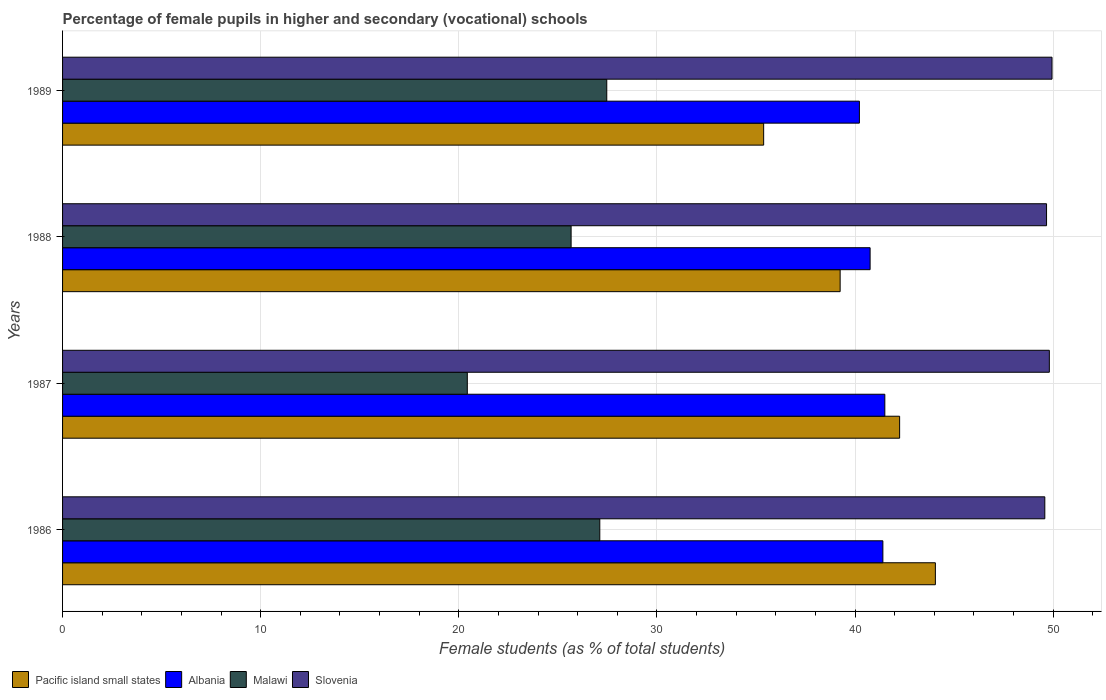How many different coloured bars are there?
Provide a short and direct response. 4. Are the number of bars per tick equal to the number of legend labels?
Offer a very short reply. Yes. What is the percentage of female pupils in higher and secondary schools in Malawi in 1987?
Provide a succinct answer. 20.43. Across all years, what is the maximum percentage of female pupils in higher and secondary schools in Slovenia?
Your answer should be very brief. 49.94. Across all years, what is the minimum percentage of female pupils in higher and secondary schools in Pacific island small states?
Offer a terse response. 35.39. In which year was the percentage of female pupils in higher and secondary schools in Albania maximum?
Offer a very short reply. 1987. What is the total percentage of female pupils in higher and secondary schools in Pacific island small states in the graph?
Your answer should be very brief. 160.95. What is the difference between the percentage of female pupils in higher and secondary schools in Malawi in 1987 and that in 1988?
Make the answer very short. -5.24. What is the difference between the percentage of female pupils in higher and secondary schools in Pacific island small states in 1988 and the percentage of female pupils in higher and secondary schools in Slovenia in 1989?
Offer a very short reply. -10.69. What is the average percentage of female pupils in higher and secondary schools in Pacific island small states per year?
Your answer should be compact. 40.24. In the year 1989, what is the difference between the percentage of female pupils in higher and secondary schools in Malawi and percentage of female pupils in higher and secondary schools in Albania?
Ensure brevity in your answer.  -12.75. In how many years, is the percentage of female pupils in higher and secondary schools in Slovenia greater than 42 %?
Provide a short and direct response. 4. What is the ratio of the percentage of female pupils in higher and secondary schools in Pacific island small states in 1987 to that in 1988?
Offer a terse response. 1.08. Is the percentage of female pupils in higher and secondary schools in Albania in 1986 less than that in 1989?
Your answer should be very brief. No. Is the difference between the percentage of female pupils in higher and secondary schools in Malawi in 1988 and 1989 greater than the difference between the percentage of female pupils in higher and secondary schools in Albania in 1988 and 1989?
Your response must be concise. No. What is the difference between the highest and the second highest percentage of female pupils in higher and secondary schools in Malawi?
Give a very brief answer. 0.35. What is the difference between the highest and the lowest percentage of female pupils in higher and secondary schools in Slovenia?
Offer a terse response. 0.36. Is the sum of the percentage of female pupils in higher and secondary schools in Slovenia in 1986 and 1988 greater than the maximum percentage of female pupils in higher and secondary schools in Malawi across all years?
Make the answer very short. Yes. Is it the case that in every year, the sum of the percentage of female pupils in higher and secondary schools in Slovenia and percentage of female pupils in higher and secondary schools in Malawi is greater than the sum of percentage of female pupils in higher and secondary schools in Albania and percentage of female pupils in higher and secondary schools in Pacific island small states?
Keep it short and to the point. No. What does the 2nd bar from the top in 1987 represents?
Provide a short and direct response. Malawi. What does the 1st bar from the bottom in 1988 represents?
Provide a short and direct response. Pacific island small states. Are all the bars in the graph horizontal?
Offer a very short reply. Yes. How many years are there in the graph?
Provide a succinct answer. 4. How many legend labels are there?
Your response must be concise. 4. How are the legend labels stacked?
Keep it short and to the point. Horizontal. What is the title of the graph?
Provide a succinct answer. Percentage of female pupils in higher and secondary (vocational) schools. What is the label or title of the X-axis?
Your answer should be very brief. Female students (as % of total students). What is the Female students (as % of total students) in Pacific island small states in 1986?
Your response must be concise. 44.06. What is the Female students (as % of total students) in Albania in 1986?
Offer a terse response. 41.41. What is the Female students (as % of total students) in Malawi in 1986?
Make the answer very short. 27.12. What is the Female students (as % of total students) of Slovenia in 1986?
Make the answer very short. 49.58. What is the Female students (as % of total students) in Pacific island small states in 1987?
Provide a succinct answer. 42.25. What is the Female students (as % of total students) in Albania in 1987?
Provide a short and direct response. 41.51. What is the Female students (as % of total students) in Malawi in 1987?
Your answer should be compact. 20.43. What is the Female students (as % of total students) of Slovenia in 1987?
Your answer should be compact. 49.81. What is the Female students (as % of total students) of Pacific island small states in 1988?
Your response must be concise. 39.25. What is the Female students (as % of total students) of Albania in 1988?
Offer a terse response. 40.76. What is the Female students (as % of total students) of Malawi in 1988?
Offer a terse response. 25.67. What is the Female students (as % of total students) in Slovenia in 1988?
Keep it short and to the point. 49.67. What is the Female students (as % of total students) of Pacific island small states in 1989?
Ensure brevity in your answer.  35.39. What is the Female students (as % of total students) in Albania in 1989?
Offer a terse response. 40.22. What is the Female students (as % of total students) in Malawi in 1989?
Your answer should be compact. 27.47. What is the Female students (as % of total students) in Slovenia in 1989?
Your answer should be very brief. 49.94. Across all years, what is the maximum Female students (as % of total students) of Pacific island small states?
Provide a succinct answer. 44.06. Across all years, what is the maximum Female students (as % of total students) of Albania?
Provide a succinct answer. 41.51. Across all years, what is the maximum Female students (as % of total students) in Malawi?
Make the answer very short. 27.47. Across all years, what is the maximum Female students (as % of total students) in Slovenia?
Provide a short and direct response. 49.94. Across all years, what is the minimum Female students (as % of total students) of Pacific island small states?
Your response must be concise. 35.39. Across all years, what is the minimum Female students (as % of total students) of Albania?
Provide a succinct answer. 40.22. Across all years, what is the minimum Female students (as % of total students) in Malawi?
Provide a short and direct response. 20.43. Across all years, what is the minimum Female students (as % of total students) of Slovenia?
Offer a terse response. 49.58. What is the total Female students (as % of total students) of Pacific island small states in the graph?
Offer a very short reply. 160.95. What is the total Female students (as % of total students) in Albania in the graph?
Keep it short and to the point. 163.9. What is the total Female students (as % of total students) in Malawi in the graph?
Your answer should be very brief. 100.69. What is the total Female students (as % of total students) in Slovenia in the graph?
Your response must be concise. 199. What is the difference between the Female students (as % of total students) in Pacific island small states in 1986 and that in 1987?
Your response must be concise. 1.8. What is the difference between the Female students (as % of total students) of Albania in 1986 and that in 1987?
Offer a very short reply. -0.1. What is the difference between the Female students (as % of total students) in Malawi in 1986 and that in 1987?
Provide a short and direct response. 6.69. What is the difference between the Female students (as % of total students) of Slovenia in 1986 and that in 1987?
Provide a succinct answer. -0.23. What is the difference between the Female students (as % of total students) in Pacific island small states in 1986 and that in 1988?
Your answer should be compact. 4.81. What is the difference between the Female students (as % of total students) of Albania in 1986 and that in 1988?
Keep it short and to the point. 0.64. What is the difference between the Female students (as % of total students) of Malawi in 1986 and that in 1988?
Make the answer very short. 1.45. What is the difference between the Female students (as % of total students) in Slovenia in 1986 and that in 1988?
Your answer should be very brief. -0.09. What is the difference between the Female students (as % of total students) in Pacific island small states in 1986 and that in 1989?
Keep it short and to the point. 8.67. What is the difference between the Female students (as % of total students) of Albania in 1986 and that in 1989?
Provide a short and direct response. 1.18. What is the difference between the Female students (as % of total students) of Malawi in 1986 and that in 1989?
Offer a terse response. -0.35. What is the difference between the Female students (as % of total students) of Slovenia in 1986 and that in 1989?
Provide a succinct answer. -0.36. What is the difference between the Female students (as % of total students) of Pacific island small states in 1987 and that in 1988?
Provide a short and direct response. 3. What is the difference between the Female students (as % of total students) in Albania in 1987 and that in 1988?
Offer a terse response. 0.74. What is the difference between the Female students (as % of total students) of Malawi in 1987 and that in 1988?
Offer a terse response. -5.24. What is the difference between the Female students (as % of total students) in Slovenia in 1987 and that in 1988?
Provide a succinct answer. 0.14. What is the difference between the Female students (as % of total students) in Pacific island small states in 1987 and that in 1989?
Offer a terse response. 6.86. What is the difference between the Female students (as % of total students) of Albania in 1987 and that in 1989?
Your answer should be very brief. 1.28. What is the difference between the Female students (as % of total students) of Malawi in 1987 and that in 1989?
Provide a succinct answer. -7.04. What is the difference between the Female students (as % of total students) in Slovenia in 1987 and that in 1989?
Provide a short and direct response. -0.14. What is the difference between the Female students (as % of total students) in Pacific island small states in 1988 and that in 1989?
Offer a terse response. 3.86. What is the difference between the Female students (as % of total students) in Albania in 1988 and that in 1989?
Offer a terse response. 0.54. What is the difference between the Female students (as % of total students) in Malawi in 1988 and that in 1989?
Make the answer very short. -1.8. What is the difference between the Female students (as % of total students) in Slovenia in 1988 and that in 1989?
Offer a terse response. -0.28. What is the difference between the Female students (as % of total students) in Pacific island small states in 1986 and the Female students (as % of total students) in Albania in 1987?
Offer a terse response. 2.55. What is the difference between the Female students (as % of total students) of Pacific island small states in 1986 and the Female students (as % of total students) of Malawi in 1987?
Give a very brief answer. 23.63. What is the difference between the Female students (as % of total students) in Pacific island small states in 1986 and the Female students (as % of total students) in Slovenia in 1987?
Give a very brief answer. -5.75. What is the difference between the Female students (as % of total students) of Albania in 1986 and the Female students (as % of total students) of Malawi in 1987?
Make the answer very short. 20.98. What is the difference between the Female students (as % of total students) in Albania in 1986 and the Female students (as % of total students) in Slovenia in 1987?
Offer a very short reply. -8.4. What is the difference between the Female students (as % of total students) of Malawi in 1986 and the Female students (as % of total students) of Slovenia in 1987?
Your answer should be very brief. -22.69. What is the difference between the Female students (as % of total students) in Pacific island small states in 1986 and the Female students (as % of total students) in Albania in 1988?
Provide a short and direct response. 3.29. What is the difference between the Female students (as % of total students) of Pacific island small states in 1986 and the Female students (as % of total students) of Malawi in 1988?
Give a very brief answer. 18.39. What is the difference between the Female students (as % of total students) of Pacific island small states in 1986 and the Female students (as % of total students) of Slovenia in 1988?
Keep it short and to the point. -5.61. What is the difference between the Female students (as % of total students) of Albania in 1986 and the Female students (as % of total students) of Malawi in 1988?
Ensure brevity in your answer.  15.74. What is the difference between the Female students (as % of total students) in Albania in 1986 and the Female students (as % of total students) in Slovenia in 1988?
Your response must be concise. -8.26. What is the difference between the Female students (as % of total students) of Malawi in 1986 and the Female students (as % of total students) of Slovenia in 1988?
Make the answer very short. -22.55. What is the difference between the Female students (as % of total students) of Pacific island small states in 1986 and the Female students (as % of total students) of Albania in 1989?
Ensure brevity in your answer.  3.83. What is the difference between the Female students (as % of total students) in Pacific island small states in 1986 and the Female students (as % of total students) in Malawi in 1989?
Your answer should be compact. 16.59. What is the difference between the Female students (as % of total students) in Pacific island small states in 1986 and the Female students (as % of total students) in Slovenia in 1989?
Your answer should be very brief. -5.89. What is the difference between the Female students (as % of total students) in Albania in 1986 and the Female students (as % of total students) in Malawi in 1989?
Ensure brevity in your answer.  13.94. What is the difference between the Female students (as % of total students) in Albania in 1986 and the Female students (as % of total students) in Slovenia in 1989?
Provide a short and direct response. -8.54. What is the difference between the Female students (as % of total students) in Malawi in 1986 and the Female students (as % of total students) in Slovenia in 1989?
Offer a terse response. -22.83. What is the difference between the Female students (as % of total students) of Pacific island small states in 1987 and the Female students (as % of total students) of Albania in 1988?
Make the answer very short. 1.49. What is the difference between the Female students (as % of total students) of Pacific island small states in 1987 and the Female students (as % of total students) of Malawi in 1988?
Make the answer very short. 16.58. What is the difference between the Female students (as % of total students) in Pacific island small states in 1987 and the Female students (as % of total students) in Slovenia in 1988?
Keep it short and to the point. -7.42. What is the difference between the Female students (as % of total students) in Albania in 1987 and the Female students (as % of total students) in Malawi in 1988?
Keep it short and to the point. 15.84. What is the difference between the Female students (as % of total students) in Albania in 1987 and the Female students (as % of total students) in Slovenia in 1988?
Offer a terse response. -8.16. What is the difference between the Female students (as % of total students) in Malawi in 1987 and the Female students (as % of total students) in Slovenia in 1988?
Ensure brevity in your answer.  -29.24. What is the difference between the Female students (as % of total students) in Pacific island small states in 1987 and the Female students (as % of total students) in Albania in 1989?
Your answer should be compact. 2.03. What is the difference between the Female students (as % of total students) of Pacific island small states in 1987 and the Female students (as % of total students) of Malawi in 1989?
Keep it short and to the point. 14.78. What is the difference between the Female students (as % of total students) of Pacific island small states in 1987 and the Female students (as % of total students) of Slovenia in 1989?
Give a very brief answer. -7.69. What is the difference between the Female students (as % of total students) of Albania in 1987 and the Female students (as % of total students) of Malawi in 1989?
Provide a succinct answer. 14.04. What is the difference between the Female students (as % of total students) in Albania in 1987 and the Female students (as % of total students) in Slovenia in 1989?
Ensure brevity in your answer.  -8.44. What is the difference between the Female students (as % of total students) in Malawi in 1987 and the Female students (as % of total students) in Slovenia in 1989?
Provide a short and direct response. -29.51. What is the difference between the Female students (as % of total students) in Pacific island small states in 1988 and the Female students (as % of total students) in Albania in 1989?
Your response must be concise. -0.97. What is the difference between the Female students (as % of total students) of Pacific island small states in 1988 and the Female students (as % of total students) of Malawi in 1989?
Provide a succinct answer. 11.78. What is the difference between the Female students (as % of total students) of Pacific island small states in 1988 and the Female students (as % of total students) of Slovenia in 1989?
Your answer should be very brief. -10.69. What is the difference between the Female students (as % of total students) in Albania in 1988 and the Female students (as % of total students) in Malawi in 1989?
Make the answer very short. 13.29. What is the difference between the Female students (as % of total students) in Albania in 1988 and the Female students (as % of total students) in Slovenia in 1989?
Make the answer very short. -9.18. What is the difference between the Female students (as % of total students) of Malawi in 1988 and the Female students (as % of total students) of Slovenia in 1989?
Provide a short and direct response. -24.28. What is the average Female students (as % of total students) of Pacific island small states per year?
Make the answer very short. 40.24. What is the average Female students (as % of total students) in Albania per year?
Give a very brief answer. 40.97. What is the average Female students (as % of total students) in Malawi per year?
Offer a terse response. 25.17. What is the average Female students (as % of total students) in Slovenia per year?
Keep it short and to the point. 49.75. In the year 1986, what is the difference between the Female students (as % of total students) of Pacific island small states and Female students (as % of total students) of Albania?
Offer a very short reply. 2.65. In the year 1986, what is the difference between the Female students (as % of total students) of Pacific island small states and Female students (as % of total students) of Malawi?
Provide a short and direct response. 16.94. In the year 1986, what is the difference between the Female students (as % of total students) in Pacific island small states and Female students (as % of total students) in Slovenia?
Provide a succinct answer. -5.52. In the year 1986, what is the difference between the Female students (as % of total students) of Albania and Female students (as % of total students) of Malawi?
Provide a succinct answer. 14.29. In the year 1986, what is the difference between the Female students (as % of total students) of Albania and Female students (as % of total students) of Slovenia?
Offer a very short reply. -8.17. In the year 1986, what is the difference between the Female students (as % of total students) in Malawi and Female students (as % of total students) in Slovenia?
Offer a terse response. -22.46. In the year 1987, what is the difference between the Female students (as % of total students) of Pacific island small states and Female students (as % of total students) of Albania?
Keep it short and to the point. 0.75. In the year 1987, what is the difference between the Female students (as % of total students) in Pacific island small states and Female students (as % of total students) in Malawi?
Keep it short and to the point. 21.82. In the year 1987, what is the difference between the Female students (as % of total students) of Pacific island small states and Female students (as % of total students) of Slovenia?
Offer a terse response. -7.56. In the year 1987, what is the difference between the Female students (as % of total students) of Albania and Female students (as % of total students) of Malawi?
Offer a terse response. 21.08. In the year 1987, what is the difference between the Female students (as % of total students) of Albania and Female students (as % of total students) of Slovenia?
Ensure brevity in your answer.  -8.3. In the year 1987, what is the difference between the Female students (as % of total students) in Malawi and Female students (as % of total students) in Slovenia?
Give a very brief answer. -29.38. In the year 1988, what is the difference between the Female students (as % of total students) in Pacific island small states and Female students (as % of total students) in Albania?
Provide a succinct answer. -1.51. In the year 1988, what is the difference between the Female students (as % of total students) in Pacific island small states and Female students (as % of total students) in Malawi?
Provide a succinct answer. 13.58. In the year 1988, what is the difference between the Female students (as % of total students) of Pacific island small states and Female students (as % of total students) of Slovenia?
Give a very brief answer. -10.42. In the year 1988, what is the difference between the Female students (as % of total students) of Albania and Female students (as % of total students) of Malawi?
Ensure brevity in your answer.  15.09. In the year 1988, what is the difference between the Female students (as % of total students) of Albania and Female students (as % of total students) of Slovenia?
Give a very brief answer. -8.91. In the year 1988, what is the difference between the Female students (as % of total students) of Malawi and Female students (as % of total students) of Slovenia?
Offer a very short reply. -24. In the year 1989, what is the difference between the Female students (as % of total students) in Pacific island small states and Female students (as % of total students) in Albania?
Give a very brief answer. -4.83. In the year 1989, what is the difference between the Female students (as % of total students) of Pacific island small states and Female students (as % of total students) of Malawi?
Your response must be concise. 7.92. In the year 1989, what is the difference between the Female students (as % of total students) of Pacific island small states and Female students (as % of total students) of Slovenia?
Offer a very short reply. -14.56. In the year 1989, what is the difference between the Female students (as % of total students) of Albania and Female students (as % of total students) of Malawi?
Your answer should be compact. 12.75. In the year 1989, what is the difference between the Female students (as % of total students) in Albania and Female students (as % of total students) in Slovenia?
Your answer should be compact. -9.72. In the year 1989, what is the difference between the Female students (as % of total students) of Malawi and Female students (as % of total students) of Slovenia?
Provide a succinct answer. -22.47. What is the ratio of the Female students (as % of total students) in Pacific island small states in 1986 to that in 1987?
Provide a short and direct response. 1.04. What is the ratio of the Female students (as % of total students) in Malawi in 1986 to that in 1987?
Make the answer very short. 1.33. What is the ratio of the Female students (as % of total students) of Slovenia in 1986 to that in 1987?
Provide a succinct answer. 1. What is the ratio of the Female students (as % of total students) of Pacific island small states in 1986 to that in 1988?
Give a very brief answer. 1.12. What is the ratio of the Female students (as % of total students) in Albania in 1986 to that in 1988?
Keep it short and to the point. 1.02. What is the ratio of the Female students (as % of total students) in Malawi in 1986 to that in 1988?
Ensure brevity in your answer.  1.06. What is the ratio of the Female students (as % of total students) of Slovenia in 1986 to that in 1988?
Offer a terse response. 1. What is the ratio of the Female students (as % of total students) in Pacific island small states in 1986 to that in 1989?
Provide a succinct answer. 1.24. What is the ratio of the Female students (as % of total students) of Albania in 1986 to that in 1989?
Ensure brevity in your answer.  1.03. What is the ratio of the Female students (as % of total students) in Malawi in 1986 to that in 1989?
Give a very brief answer. 0.99. What is the ratio of the Female students (as % of total students) of Slovenia in 1986 to that in 1989?
Provide a short and direct response. 0.99. What is the ratio of the Female students (as % of total students) in Pacific island small states in 1987 to that in 1988?
Make the answer very short. 1.08. What is the ratio of the Female students (as % of total students) in Albania in 1987 to that in 1988?
Provide a short and direct response. 1.02. What is the ratio of the Female students (as % of total students) of Malawi in 1987 to that in 1988?
Provide a succinct answer. 0.8. What is the ratio of the Female students (as % of total students) in Slovenia in 1987 to that in 1988?
Ensure brevity in your answer.  1. What is the ratio of the Female students (as % of total students) of Pacific island small states in 1987 to that in 1989?
Make the answer very short. 1.19. What is the ratio of the Female students (as % of total students) in Albania in 1987 to that in 1989?
Offer a terse response. 1.03. What is the ratio of the Female students (as % of total students) in Malawi in 1987 to that in 1989?
Provide a succinct answer. 0.74. What is the ratio of the Female students (as % of total students) of Pacific island small states in 1988 to that in 1989?
Your answer should be compact. 1.11. What is the ratio of the Female students (as % of total students) of Albania in 1988 to that in 1989?
Provide a succinct answer. 1.01. What is the ratio of the Female students (as % of total students) in Malawi in 1988 to that in 1989?
Your response must be concise. 0.93. What is the difference between the highest and the second highest Female students (as % of total students) in Pacific island small states?
Give a very brief answer. 1.8. What is the difference between the highest and the second highest Female students (as % of total students) of Albania?
Your answer should be compact. 0.1. What is the difference between the highest and the second highest Female students (as % of total students) in Malawi?
Your answer should be compact. 0.35. What is the difference between the highest and the second highest Female students (as % of total students) of Slovenia?
Make the answer very short. 0.14. What is the difference between the highest and the lowest Female students (as % of total students) of Pacific island small states?
Your response must be concise. 8.67. What is the difference between the highest and the lowest Female students (as % of total students) in Albania?
Your answer should be very brief. 1.28. What is the difference between the highest and the lowest Female students (as % of total students) of Malawi?
Provide a succinct answer. 7.04. What is the difference between the highest and the lowest Female students (as % of total students) in Slovenia?
Make the answer very short. 0.36. 